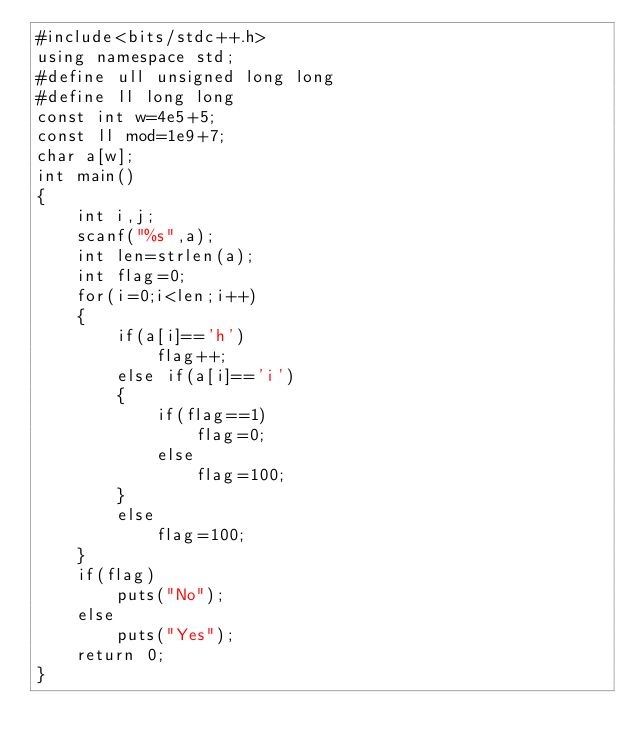Convert code to text. <code><loc_0><loc_0><loc_500><loc_500><_C++_>#include<bits/stdc++.h>
using namespace std;
#define ull unsigned long long
#define ll long long
const int w=4e5+5;
const ll mod=1e9+7;
char a[w];
int main()
{
    int i,j;
    scanf("%s",a);
    int len=strlen(a);
    int flag=0;
    for(i=0;i<len;i++)
    {
        if(a[i]=='h')
            flag++;
        else if(a[i]=='i')
        {
            if(flag==1)
                flag=0;
            else
                flag=100;
        }
        else
            flag=100;
    }
    if(flag)
        puts("No");
    else
        puts("Yes");
    return 0;
}
</code> 